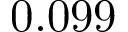Convert formula to latex. <formula><loc_0><loc_0><loc_500><loc_500>0 . 0 9 9</formula> 